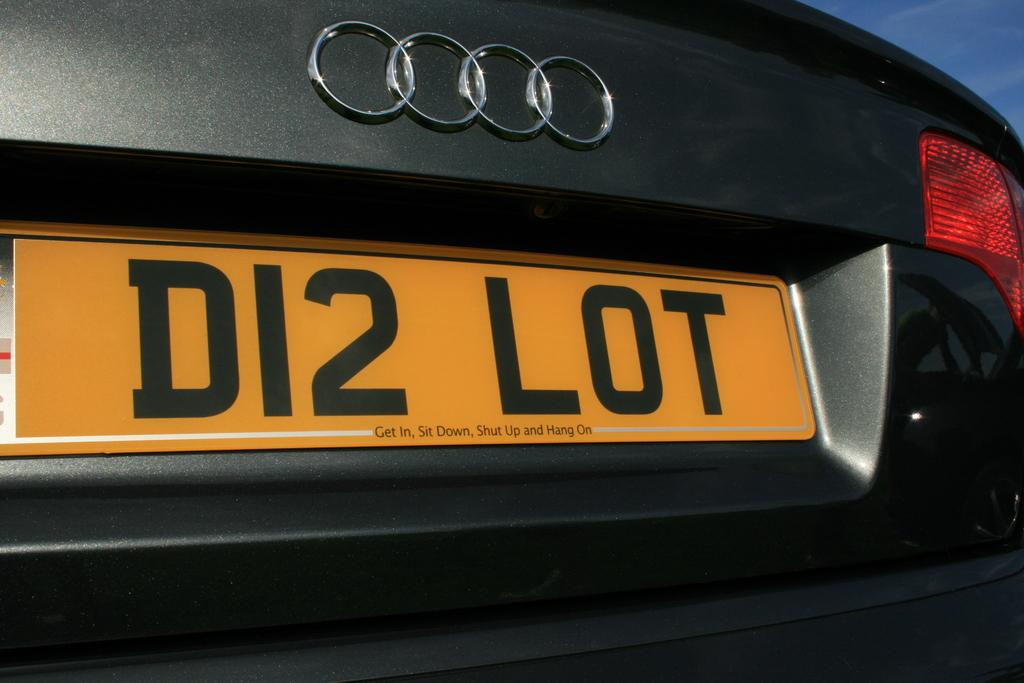Provide a one-sentence caption for the provided image. A black car has a license plate with the text D12 LOT. 